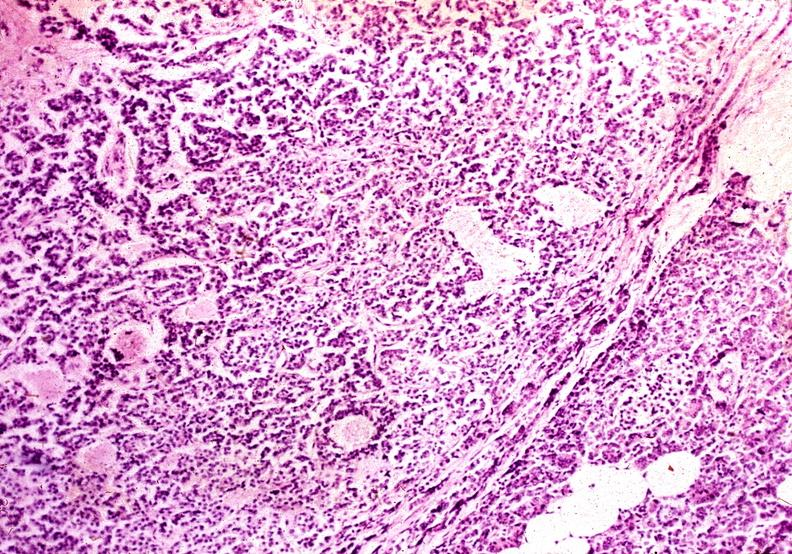does pancreas show islet cell carcinoma?
Answer the question using a single word or phrase. No 